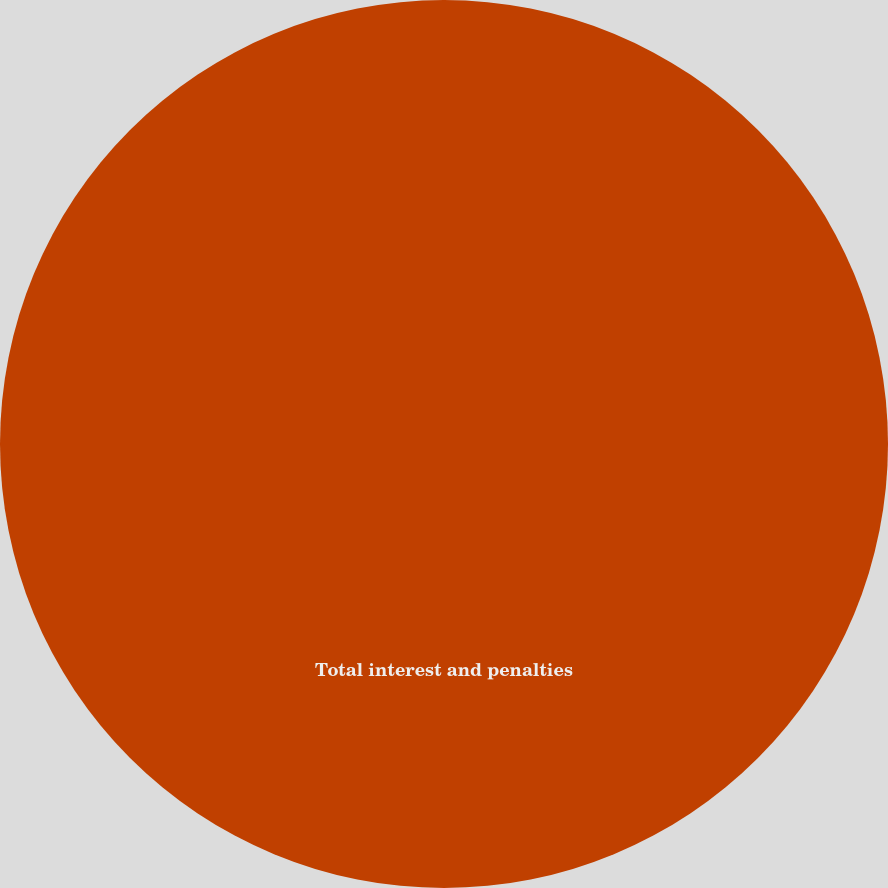Convert chart. <chart><loc_0><loc_0><loc_500><loc_500><pie_chart><fcel>Total interest and penalties<nl><fcel>100.0%<nl></chart> 